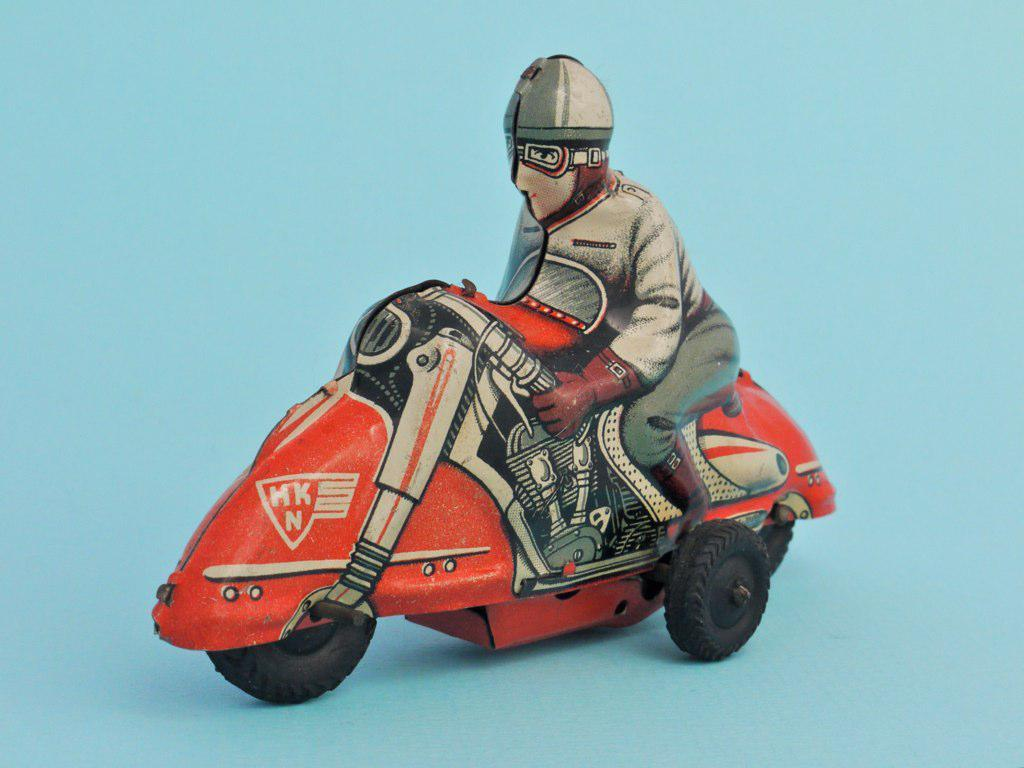What type of image is being described? The image is a cartoon. What is the main subject of the cartoon? The cartoon depicts a person. What is the person doing in the cartoon? The person is on a bike. What color is the bike in the cartoon? The bike is red in color. What type of cabbage is being used as a helmet in the cartoon? There is no cabbage or helmet present in the cartoon; the person is simply riding a red bike. 